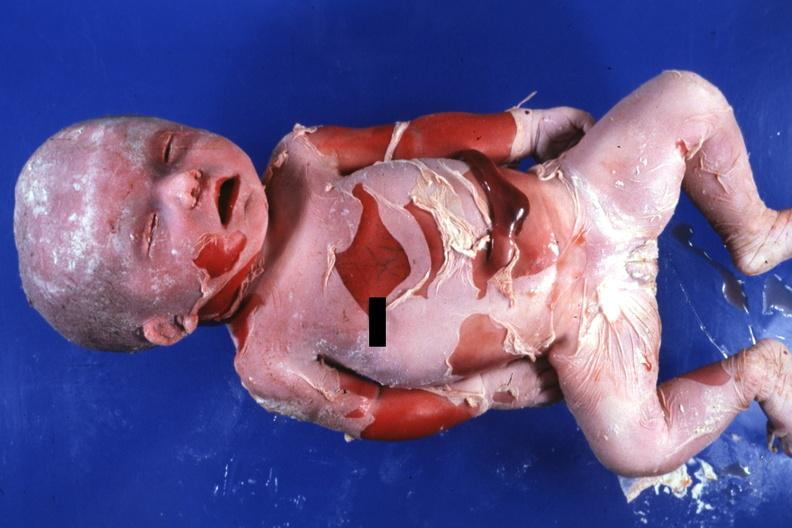s surface advanced typical?
Answer the question using a single word or phrase. No 